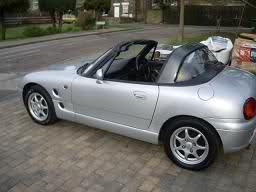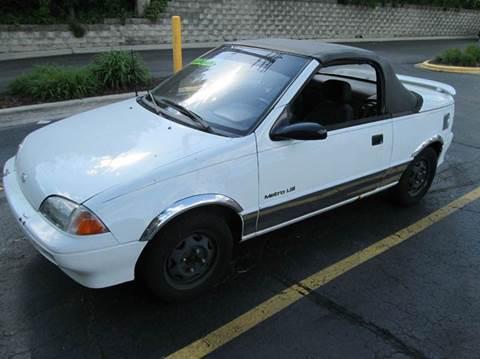The first image is the image on the left, the second image is the image on the right. Examine the images to the left and right. Is the description "The car on the right has its top down." accurate? Answer yes or no. No. The first image is the image on the left, the second image is the image on the right. Considering the images on both sides, is "An image shows a yellow car parked and facing leftward." valid? Answer yes or no. No. 